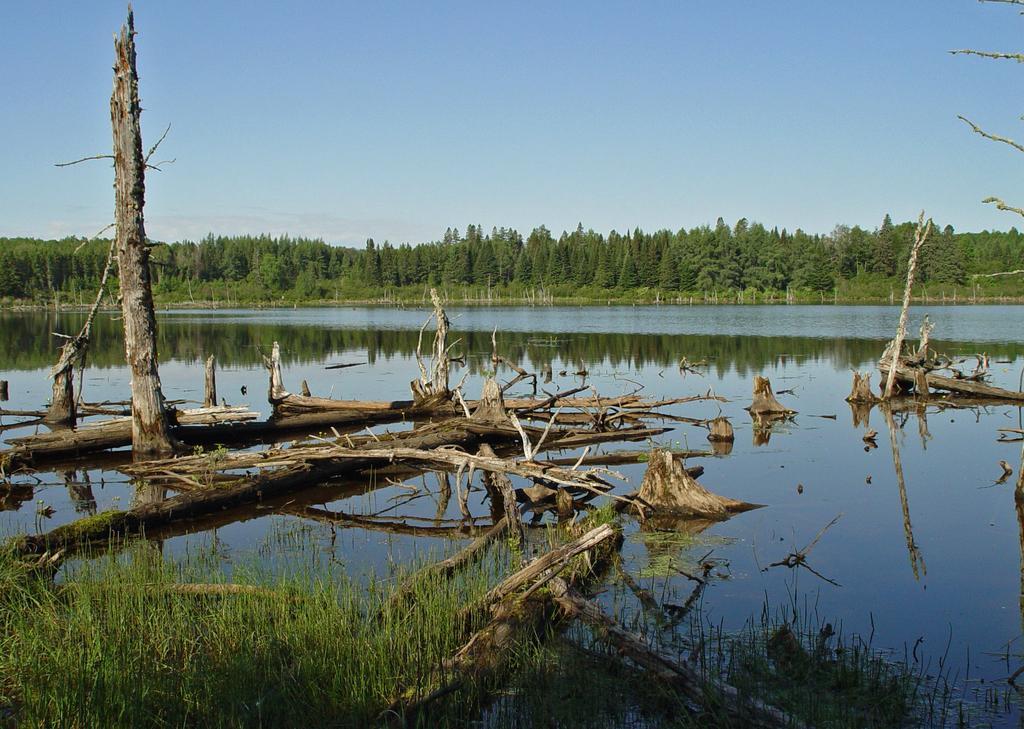Could you give a brief overview of what you see in this image? There are some wooden logs are present on the surface of a water. There are some trees in the background, and there is a sky at the top of this image. 